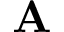Convert formula to latex. <formula><loc_0><loc_0><loc_500><loc_500>A</formula> 